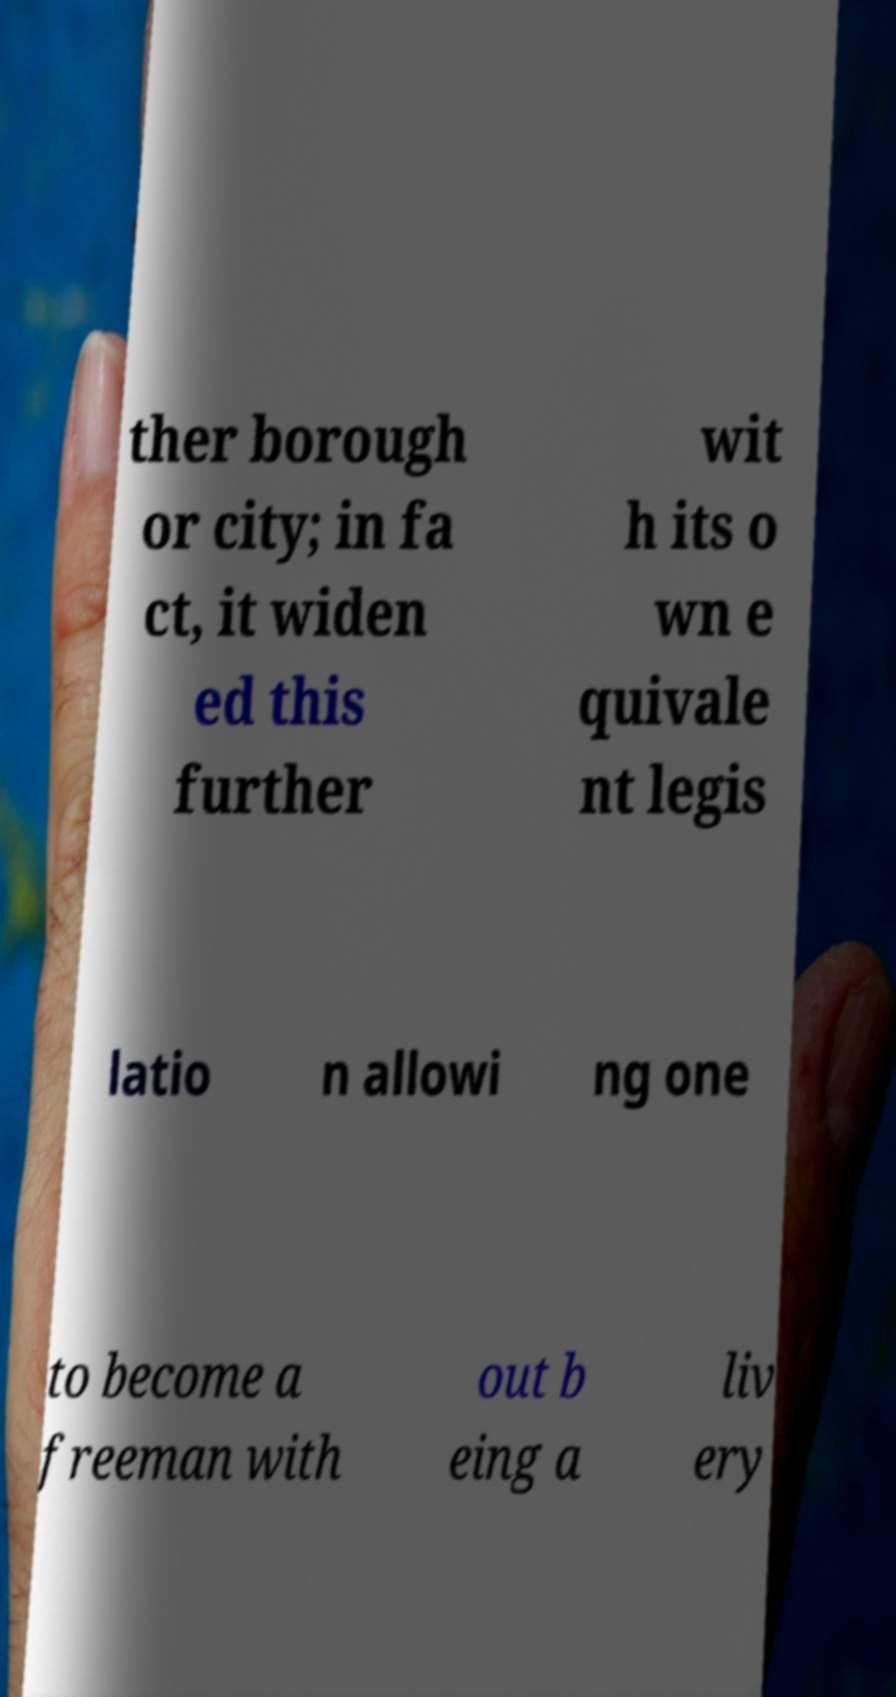I need the written content from this picture converted into text. Can you do that? ther borough or city; in fa ct, it widen ed this further wit h its o wn e quivale nt legis latio n allowi ng one to become a freeman with out b eing a liv ery 